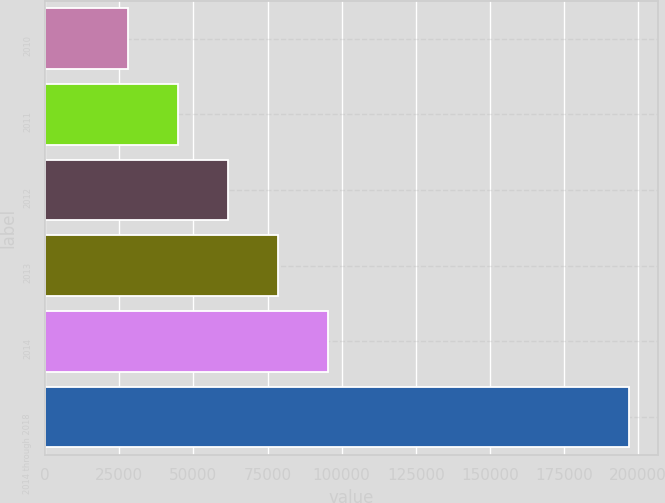<chart> <loc_0><loc_0><loc_500><loc_500><bar_chart><fcel>2010<fcel>2011<fcel>2012<fcel>2013<fcel>2014<fcel>2014 through 2018<nl><fcel>27775<fcel>44691.3<fcel>61607.6<fcel>78523.9<fcel>95440.2<fcel>196938<nl></chart> 